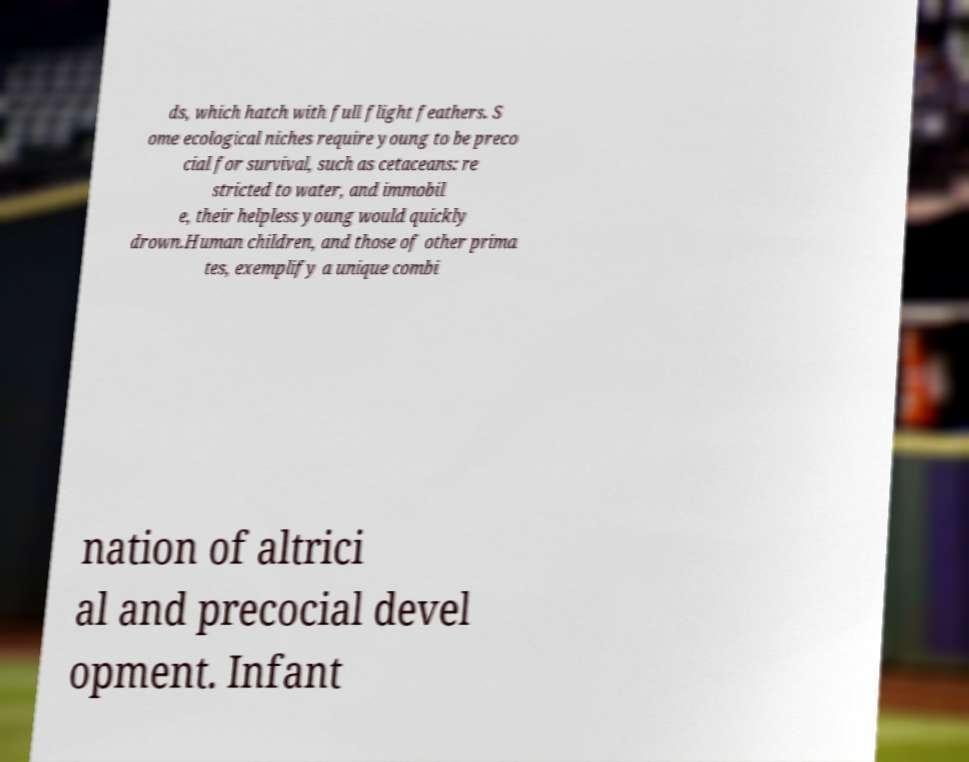I need the written content from this picture converted into text. Can you do that? ds, which hatch with full flight feathers. S ome ecological niches require young to be preco cial for survival, such as cetaceans: re stricted to water, and immobil e, their helpless young would quickly drown.Human children, and those of other prima tes, exemplify a unique combi nation of altrici al and precocial devel opment. Infant 